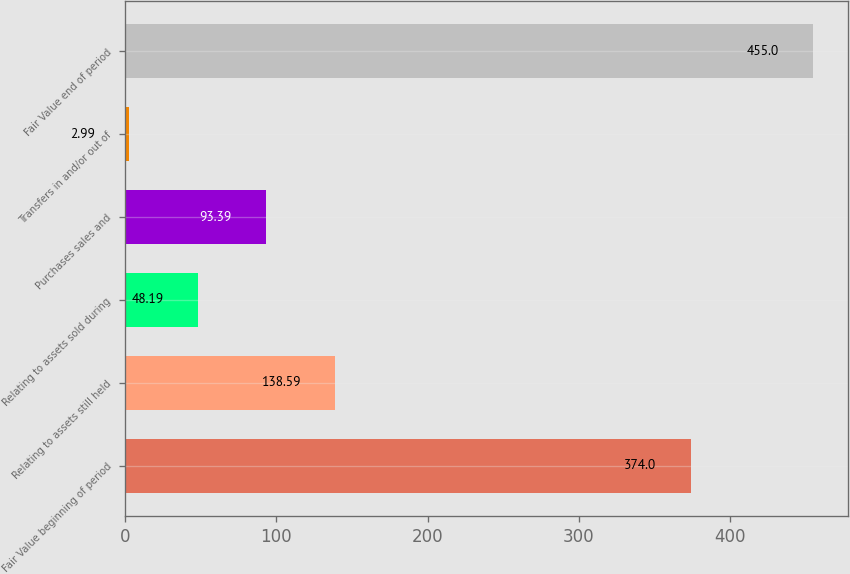Convert chart to OTSL. <chart><loc_0><loc_0><loc_500><loc_500><bar_chart><fcel>Fair Value beginning of period<fcel>Relating to assets still held<fcel>Relating to assets sold during<fcel>Purchases sales and<fcel>Transfers in and/or out of<fcel>Fair Value end of period<nl><fcel>374<fcel>138.59<fcel>48.19<fcel>93.39<fcel>2.99<fcel>455<nl></chart> 